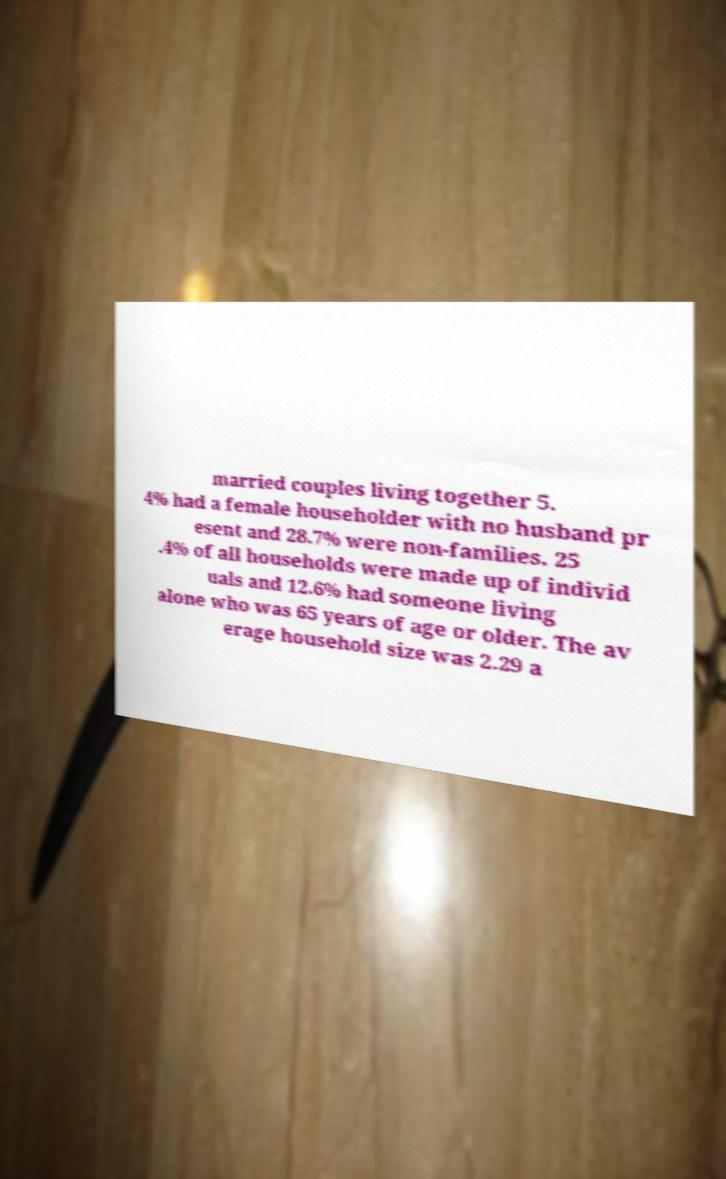Can you accurately transcribe the text from the provided image for me? married couples living together 5. 4% had a female householder with no husband pr esent and 28.7% were non-families. 25 .4% of all households were made up of individ uals and 12.6% had someone living alone who was 65 years of age or older. The av erage household size was 2.29 a 